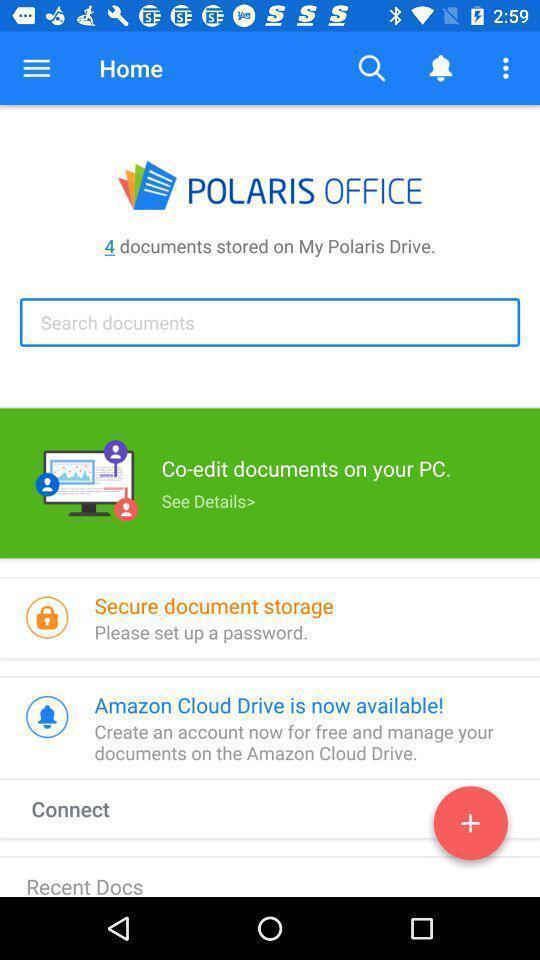Describe the visual elements of this screenshot. Page showing different documents stored. 